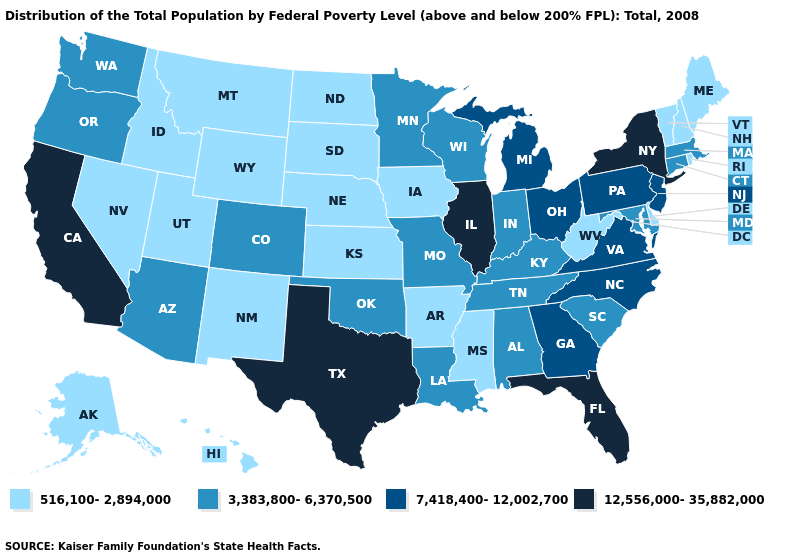What is the value of Wisconsin?
Be succinct. 3,383,800-6,370,500. Does Maine have the lowest value in the Northeast?
Concise answer only. Yes. What is the value of Utah?
Short answer required. 516,100-2,894,000. What is the highest value in the USA?
Concise answer only. 12,556,000-35,882,000. What is the value of Washington?
Concise answer only. 3,383,800-6,370,500. Is the legend a continuous bar?
Keep it brief. No. Name the states that have a value in the range 3,383,800-6,370,500?
Short answer required. Alabama, Arizona, Colorado, Connecticut, Indiana, Kentucky, Louisiana, Maryland, Massachusetts, Minnesota, Missouri, Oklahoma, Oregon, South Carolina, Tennessee, Washington, Wisconsin. Is the legend a continuous bar?
Write a very short answer. No. Among the states that border Washington , does Idaho have the lowest value?
Write a very short answer. Yes. Does the map have missing data?
Concise answer only. No. Name the states that have a value in the range 516,100-2,894,000?
Give a very brief answer. Alaska, Arkansas, Delaware, Hawaii, Idaho, Iowa, Kansas, Maine, Mississippi, Montana, Nebraska, Nevada, New Hampshire, New Mexico, North Dakota, Rhode Island, South Dakota, Utah, Vermont, West Virginia, Wyoming. Name the states that have a value in the range 12,556,000-35,882,000?
Keep it brief. California, Florida, Illinois, New York, Texas. Name the states that have a value in the range 12,556,000-35,882,000?
Keep it brief. California, Florida, Illinois, New York, Texas. Which states have the lowest value in the USA?
Answer briefly. Alaska, Arkansas, Delaware, Hawaii, Idaho, Iowa, Kansas, Maine, Mississippi, Montana, Nebraska, Nevada, New Hampshire, New Mexico, North Dakota, Rhode Island, South Dakota, Utah, Vermont, West Virginia, Wyoming. 